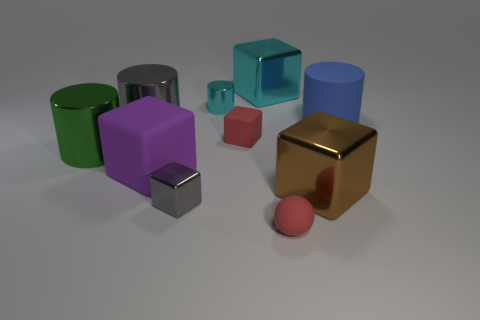Can you tell me which shapes are present in the image and their colors? In the image, there are various 3D shapes including a green cylinder, a silver cylinder, a purple cube, a red cube, a teal cube, a blue cylinder, and a gold cube. Additionally, there is a small red sphere. Which objects seem to have a reflective surface? The golden cube, the silver cylinder, and the smaller metallic cube seem to have highly reflective surfaces, as indicated by the distinct light reflections visible on them. 